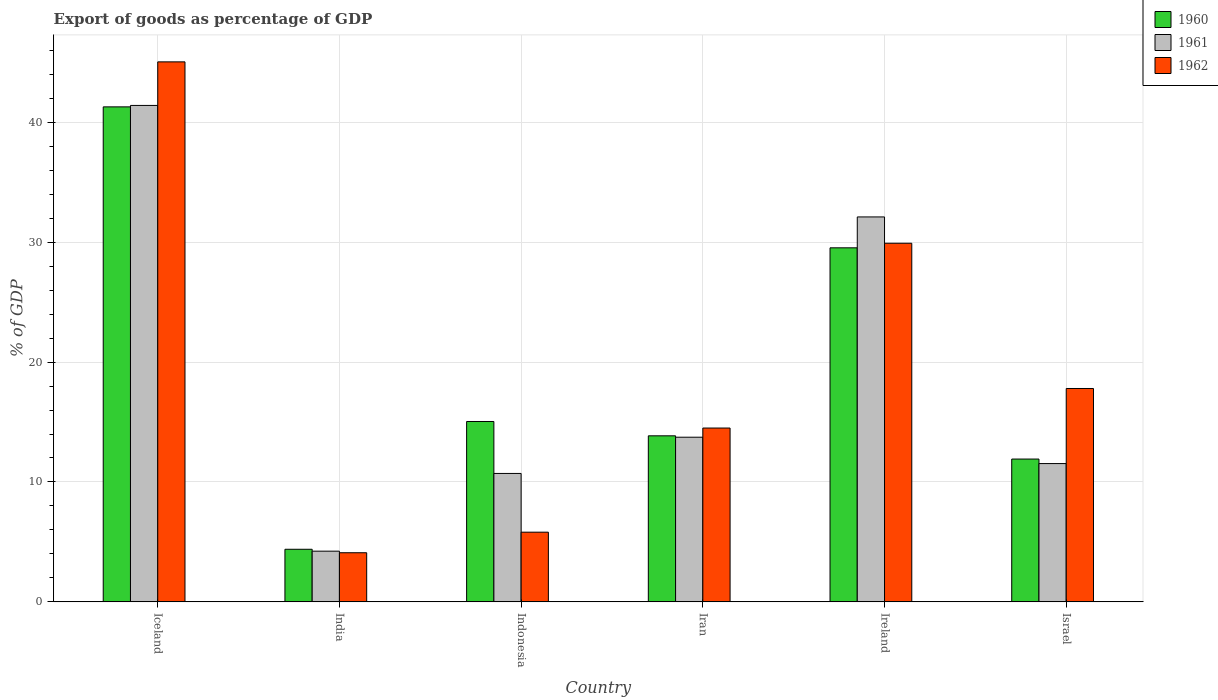How many groups of bars are there?
Make the answer very short. 6. Are the number of bars per tick equal to the number of legend labels?
Your response must be concise. Yes. How many bars are there on the 2nd tick from the left?
Your response must be concise. 3. How many bars are there on the 4th tick from the right?
Ensure brevity in your answer.  3. What is the label of the 4th group of bars from the left?
Provide a succinct answer. Iran. What is the export of goods as percentage of GDP in 1960 in Ireland?
Ensure brevity in your answer.  29.53. Across all countries, what is the maximum export of goods as percentage of GDP in 1960?
Keep it short and to the point. 41.28. Across all countries, what is the minimum export of goods as percentage of GDP in 1960?
Ensure brevity in your answer.  4.39. In which country was the export of goods as percentage of GDP in 1961 maximum?
Ensure brevity in your answer.  Iceland. What is the total export of goods as percentage of GDP in 1962 in the graph?
Keep it short and to the point. 117.15. What is the difference between the export of goods as percentage of GDP in 1960 in India and that in Indonesia?
Ensure brevity in your answer.  -10.66. What is the difference between the export of goods as percentage of GDP in 1960 in Iceland and the export of goods as percentage of GDP in 1962 in Iran?
Your answer should be compact. 26.79. What is the average export of goods as percentage of GDP in 1961 per country?
Your response must be concise. 18.95. What is the difference between the export of goods as percentage of GDP of/in 1961 and export of goods as percentage of GDP of/in 1962 in Iceland?
Give a very brief answer. -3.63. What is the ratio of the export of goods as percentage of GDP in 1960 in Indonesia to that in Israel?
Keep it short and to the point. 1.26. Is the export of goods as percentage of GDP in 1960 in Indonesia less than that in Ireland?
Make the answer very short. Yes. Is the difference between the export of goods as percentage of GDP in 1961 in Iceland and Iran greater than the difference between the export of goods as percentage of GDP in 1962 in Iceland and Iran?
Give a very brief answer. No. What is the difference between the highest and the second highest export of goods as percentage of GDP in 1960?
Give a very brief answer. 11.76. What is the difference between the highest and the lowest export of goods as percentage of GDP in 1961?
Your response must be concise. 37.17. How many bars are there?
Offer a very short reply. 18. Are all the bars in the graph horizontal?
Give a very brief answer. No. How many countries are there in the graph?
Your answer should be very brief. 6. What is the difference between two consecutive major ticks on the Y-axis?
Offer a terse response. 10. Are the values on the major ticks of Y-axis written in scientific E-notation?
Your answer should be compact. No. Does the graph contain any zero values?
Keep it short and to the point. No. What is the title of the graph?
Keep it short and to the point. Export of goods as percentage of GDP. What is the label or title of the X-axis?
Provide a short and direct response. Country. What is the label or title of the Y-axis?
Give a very brief answer. % of GDP. What is the % of GDP of 1960 in Iceland?
Provide a succinct answer. 41.28. What is the % of GDP in 1961 in Iceland?
Provide a short and direct response. 41.4. What is the % of GDP in 1962 in Iceland?
Your answer should be very brief. 45.03. What is the % of GDP of 1960 in India?
Provide a succinct answer. 4.39. What is the % of GDP in 1961 in India?
Provide a succinct answer. 4.23. What is the % of GDP of 1962 in India?
Make the answer very short. 4.1. What is the % of GDP in 1960 in Indonesia?
Provide a short and direct response. 15.04. What is the % of GDP of 1961 in Indonesia?
Provide a short and direct response. 10.71. What is the % of GDP in 1962 in Indonesia?
Your answer should be compact. 5.81. What is the % of GDP in 1960 in Iran?
Your answer should be compact. 13.85. What is the % of GDP of 1961 in Iran?
Ensure brevity in your answer.  13.73. What is the % of GDP in 1962 in Iran?
Offer a terse response. 14.5. What is the % of GDP in 1960 in Ireland?
Your answer should be compact. 29.53. What is the % of GDP in 1961 in Ireland?
Keep it short and to the point. 32.1. What is the % of GDP in 1962 in Ireland?
Offer a very short reply. 29.91. What is the % of GDP in 1960 in Israel?
Offer a very short reply. 11.91. What is the % of GDP in 1961 in Israel?
Give a very brief answer. 11.53. What is the % of GDP in 1962 in Israel?
Offer a terse response. 17.8. Across all countries, what is the maximum % of GDP of 1960?
Provide a succinct answer. 41.28. Across all countries, what is the maximum % of GDP of 1961?
Give a very brief answer. 41.4. Across all countries, what is the maximum % of GDP in 1962?
Give a very brief answer. 45.03. Across all countries, what is the minimum % of GDP in 1960?
Keep it short and to the point. 4.39. Across all countries, what is the minimum % of GDP of 1961?
Ensure brevity in your answer.  4.23. Across all countries, what is the minimum % of GDP in 1962?
Make the answer very short. 4.1. What is the total % of GDP in 1960 in the graph?
Provide a succinct answer. 116. What is the total % of GDP of 1961 in the graph?
Offer a very short reply. 113.71. What is the total % of GDP in 1962 in the graph?
Give a very brief answer. 117.15. What is the difference between the % of GDP of 1960 in Iceland and that in India?
Provide a short and direct response. 36.9. What is the difference between the % of GDP in 1961 in Iceland and that in India?
Give a very brief answer. 37.17. What is the difference between the % of GDP in 1962 in Iceland and that in India?
Your response must be concise. 40.94. What is the difference between the % of GDP in 1960 in Iceland and that in Indonesia?
Offer a very short reply. 26.24. What is the difference between the % of GDP in 1961 in Iceland and that in Indonesia?
Offer a very short reply. 30.69. What is the difference between the % of GDP of 1962 in Iceland and that in Indonesia?
Provide a succinct answer. 39.22. What is the difference between the % of GDP of 1960 in Iceland and that in Iran?
Keep it short and to the point. 27.43. What is the difference between the % of GDP in 1961 in Iceland and that in Iran?
Your answer should be very brief. 27.67. What is the difference between the % of GDP of 1962 in Iceland and that in Iran?
Your answer should be compact. 30.54. What is the difference between the % of GDP of 1960 in Iceland and that in Ireland?
Your answer should be very brief. 11.76. What is the difference between the % of GDP in 1961 in Iceland and that in Ireland?
Your response must be concise. 9.3. What is the difference between the % of GDP of 1962 in Iceland and that in Ireland?
Your answer should be very brief. 15.13. What is the difference between the % of GDP in 1960 in Iceland and that in Israel?
Provide a succinct answer. 29.37. What is the difference between the % of GDP in 1961 in Iceland and that in Israel?
Ensure brevity in your answer.  29.87. What is the difference between the % of GDP of 1962 in Iceland and that in Israel?
Provide a succinct answer. 27.24. What is the difference between the % of GDP in 1960 in India and that in Indonesia?
Give a very brief answer. -10.66. What is the difference between the % of GDP in 1961 in India and that in Indonesia?
Ensure brevity in your answer.  -6.48. What is the difference between the % of GDP in 1962 in India and that in Indonesia?
Your answer should be very brief. -1.72. What is the difference between the % of GDP of 1960 in India and that in Iran?
Your answer should be very brief. -9.46. What is the difference between the % of GDP of 1961 in India and that in Iran?
Offer a terse response. -9.5. What is the difference between the % of GDP of 1962 in India and that in Iran?
Offer a terse response. -10.4. What is the difference between the % of GDP in 1960 in India and that in Ireland?
Your response must be concise. -25.14. What is the difference between the % of GDP of 1961 in India and that in Ireland?
Ensure brevity in your answer.  -27.87. What is the difference between the % of GDP in 1962 in India and that in Ireland?
Keep it short and to the point. -25.81. What is the difference between the % of GDP of 1960 in India and that in Israel?
Provide a short and direct response. -7.52. What is the difference between the % of GDP of 1961 in India and that in Israel?
Make the answer very short. -7.3. What is the difference between the % of GDP of 1962 in India and that in Israel?
Make the answer very short. -13.7. What is the difference between the % of GDP of 1960 in Indonesia and that in Iran?
Provide a succinct answer. 1.19. What is the difference between the % of GDP of 1961 in Indonesia and that in Iran?
Make the answer very short. -3.02. What is the difference between the % of GDP in 1962 in Indonesia and that in Iran?
Your response must be concise. -8.68. What is the difference between the % of GDP of 1960 in Indonesia and that in Ireland?
Offer a terse response. -14.48. What is the difference between the % of GDP in 1961 in Indonesia and that in Ireland?
Your answer should be compact. -21.39. What is the difference between the % of GDP of 1962 in Indonesia and that in Ireland?
Offer a terse response. -24.1. What is the difference between the % of GDP of 1960 in Indonesia and that in Israel?
Make the answer very short. 3.13. What is the difference between the % of GDP of 1961 in Indonesia and that in Israel?
Give a very brief answer. -0.82. What is the difference between the % of GDP in 1962 in Indonesia and that in Israel?
Keep it short and to the point. -11.98. What is the difference between the % of GDP of 1960 in Iran and that in Ireland?
Provide a short and direct response. -15.68. What is the difference between the % of GDP in 1961 in Iran and that in Ireland?
Offer a terse response. -18.37. What is the difference between the % of GDP in 1962 in Iran and that in Ireland?
Give a very brief answer. -15.41. What is the difference between the % of GDP of 1960 in Iran and that in Israel?
Provide a short and direct response. 1.94. What is the difference between the % of GDP in 1961 in Iran and that in Israel?
Give a very brief answer. 2.2. What is the difference between the % of GDP of 1962 in Iran and that in Israel?
Keep it short and to the point. -3.3. What is the difference between the % of GDP of 1960 in Ireland and that in Israel?
Provide a short and direct response. 17.62. What is the difference between the % of GDP of 1961 in Ireland and that in Israel?
Your response must be concise. 20.57. What is the difference between the % of GDP of 1962 in Ireland and that in Israel?
Your answer should be very brief. 12.11. What is the difference between the % of GDP in 1960 in Iceland and the % of GDP in 1961 in India?
Your response must be concise. 37.05. What is the difference between the % of GDP of 1960 in Iceland and the % of GDP of 1962 in India?
Your answer should be very brief. 37.19. What is the difference between the % of GDP of 1961 in Iceland and the % of GDP of 1962 in India?
Provide a short and direct response. 37.3. What is the difference between the % of GDP in 1960 in Iceland and the % of GDP in 1961 in Indonesia?
Provide a succinct answer. 30.57. What is the difference between the % of GDP in 1960 in Iceland and the % of GDP in 1962 in Indonesia?
Provide a short and direct response. 35.47. What is the difference between the % of GDP in 1961 in Iceland and the % of GDP in 1962 in Indonesia?
Give a very brief answer. 35.59. What is the difference between the % of GDP of 1960 in Iceland and the % of GDP of 1961 in Iran?
Provide a succinct answer. 27.55. What is the difference between the % of GDP of 1960 in Iceland and the % of GDP of 1962 in Iran?
Your answer should be very brief. 26.79. What is the difference between the % of GDP of 1961 in Iceland and the % of GDP of 1962 in Iran?
Your answer should be very brief. 26.9. What is the difference between the % of GDP in 1960 in Iceland and the % of GDP in 1961 in Ireland?
Your response must be concise. 9.18. What is the difference between the % of GDP in 1960 in Iceland and the % of GDP in 1962 in Ireland?
Make the answer very short. 11.37. What is the difference between the % of GDP of 1961 in Iceland and the % of GDP of 1962 in Ireland?
Offer a very short reply. 11.49. What is the difference between the % of GDP of 1960 in Iceland and the % of GDP of 1961 in Israel?
Make the answer very short. 29.75. What is the difference between the % of GDP in 1960 in Iceland and the % of GDP in 1962 in Israel?
Your response must be concise. 23.49. What is the difference between the % of GDP of 1961 in Iceland and the % of GDP of 1962 in Israel?
Your answer should be very brief. 23.61. What is the difference between the % of GDP of 1960 in India and the % of GDP of 1961 in Indonesia?
Provide a succinct answer. -6.32. What is the difference between the % of GDP in 1960 in India and the % of GDP in 1962 in Indonesia?
Your response must be concise. -1.43. What is the difference between the % of GDP of 1961 in India and the % of GDP of 1962 in Indonesia?
Provide a succinct answer. -1.58. What is the difference between the % of GDP in 1960 in India and the % of GDP in 1961 in Iran?
Offer a terse response. -9.35. What is the difference between the % of GDP in 1960 in India and the % of GDP in 1962 in Iran?
Offer a very short reply. -10.11. What is the difference between the % of GDP of 1961 in India and the % of GDP of 1962 in Iran?
Ensure brevity in your answer.  -10.27. What is the difference between the % of GDP in 1960 in India and the % of GDP in 1961 in Ireland?
Keep it short and to the point. -27.72. What is the difference between the % of GDP in 1960 in India and the % of GDP in 1962 in Ireland?
Offer a terse response. -25.52. What is the difference between the % of GDP in 1961 in India and the % of GDP in 1962 in Ireland?
Ensure brevity in your answer.  -25.68. What is the difference between the % of GDP of 1960 in India and the % of GDP of 1961 in Israel?
Your answer should be very brief. -7.15. What is the difference between the % of GDP of 1960 in India and the % of GDP of 1962 in Israel?
Provide a succinct answer. -13.41. What is the difference between the % of GDP of 1961 in India and the % of GDP of 1962 in Israel?
Make the answer very short. -13.57. What is the difference between the % of GDP of 1960 in Indonesia and the % of GDP of 1961 in Iran?
Your answer should be compact. 1.31. What is the difference between the % of GDP in 1960 in Indonesia and the % of GDP in 1962 in Iran?
Give a very brief answer. 0.55. What is the difference between the % of GDP of 1961 in Indonesia and the % of GDP of 1962 in Iran?
Make the answer very short. -3.79. What is the difference between the % of GDP in 1960 in Indonesia and the % of GDP in 1961 in Ireland?
Make the answer very short. -17.06. What is the difference between the % of GDP in 1960 in Indonesia and the % of GDP in 1962 in Ireland?
Offer a very short reply. -14.86. What is the difference between the % of GDP of 1961 in Indonesia and the % of GDP of 1962 in Ireland?
Keep it short and to the point. -19.2. What is the difference between the % of GDP of 1960 in Indonesia and the % of GDP of 1961 in Israel?
Your answer should be very brief. 3.51. What is the difference between the % of GDP of 1960 in Indonesia and the % of GDP of 1962 in Israel?
Offer a very short reply. -2.75. What is the difference between the % of GDP of 1961 in Indonesia and the % of GDP of 1962 in Israel?
Ensure brevity in your answer.  -7.08. What is the difference between the % of GDP of 1960 in Iran and the % of GDP of 1961 in Ireland?
Your answer should be compact. -18.25. What is the difference between the % of GDP in 1960 in Iran and the % of GDP in 1962 in Ireland?
Give a very brief answer. -16.06. What is the difference between the % of GDP in 1961 in Iran and the % of GDP in 1962 in Ireland?
Offer a very short reply. -16.18. What is the difference between the % of GDP in 1960 in Iran and the % of GDP in 1961 in Israel?
Your answer should be compact. 2.31. What is the difference between the % of GDP in 1960 in Iran and the % of GDP in 1962 in Israel?
Provide a short and direct response. -3.95. What is the difference between the % of GDP of 1961 in Iran and the % of GDP of 1962 in Israel?
Make the answer very short. -4.06. What is the difference between the % of GDP of 1960 in Ireland and the % of GDP of 1961 in Israel?
Offer a very short reply. 17.99. What is the difference between the % of GDP in 1960 in Ireland and the % of GDP in 1962 in Israel?
Provide a succinct answer. 11.73. What is the difference between the % of GDP in 1961 in Ireland and the % of GDP in 1962 in Israel?
Make the answer very short. 14.31. What is the average % of GDP of 1960 per country?
Your answer should be compact. 19.33. What is the average % of GDP in 1961 per country?
Provide a succinct answer. 18.95. What is the average % of GDP of 1962 per country?
Make the answer very short. 19.52. What is the difference between the % of GDP in 1960 and % of GDP in 1961 in Iceland?
Provide a succinct answer. -0.12. What is the difference between the % of GDP in 1960 and % of GDP in 1962 in Iceland?
Provide a succinct answer. -3.75. What is the difference between the % of GDP in 1961 and % of GDP in 1962 in Iceland?
Your response must be concise. -3.63. What is the difference between the % of GDP in 1960 and % of GDP in 1961 in India?
Offer a terse response. 0.16. What is the difference between the % of GDP in 1960 and % of GDP in 1962 in India?
Make the answer very short. 0.29. What is the difference between the % of GDP in 1961 and % of GDP in 1962 in India?
Give a very brief answer. 0.13. What is the difference between the % of GDP of 1960 and % of GDP of 1961 in Indonesia?
Make the answer very short. 4.33. What is the difference between the % of GDP of 1960 and % of GDP of 1962 in Indonesia?
Ensure brevity in your answer.  9.23. What is the difference between the % of GDP of 1961 and % of GDP of 1962 in Indonesia?
Make the answer very short. 4.9. What is the difference between the % of GDP of 1960 and % of GDP of 1961 in Iran?
Give a very brief answer. 0.12. What is the difference between the % of GDP in 1960 and % of GDP in 1962 in Iran?
Your answer should be very brief. -0.65. What is the difference between the % of GDP in 1961 and % of GDP in 1962 in Iran?
Your response must be concise. -0.77. What is the difference between the % of GDP of 1960 and % of GDP of 1961 in Ireland?
Your response must be concise. -2.58. What is the difference between the % of GDP of 1960 and % of GDP of 1962 in Ireland?
Provide a short and direct response. -0.38. What is the difference between the % of GDP of 1961 and % of GDP of 1962 in Ireland?
Offer a terse response. 2.2. What is the difference between the % of GDP of 1960 and % of GDP of 1961 in Israel?
Keep it short and to the point. 0.38. What is the difference between the % of GDP of 1960 and % of GDP of 1962 in Israel?
Give a very brief answer. -5.88. What is the difference between the % of GDP in 1961 and % of GDP in 1962 in Israel?
Offer a terse response. -6.26. What is the ratio of the % of GDP in 1960 in Iceland to that in India?
Your answer should be compact. 9.41. What is the ratio of the % of GDP of 1961 in Iceland to that in India?
Ensure brevity in your answer.  9.79. What is the ratio of the % of GDP in 1962 in Iceland to that in India?
Offer a very short reply. 10.99. What is the ratio of the % of GDP of 1960 in Iceland to that in Indonesia?
Give a very brief answer. 2.74. What is the ratio of the % of GDP in 1961 in Iceland to that in Indonesia?
Your response must be concise. 3.87. What is the ratio of the % of GDP in 1962 in Iceland to that in Indonesia?
Offer a very short reply. 7.75. What is the ratio of the % of GDP in 1960 in Iceland to that in Iran?
Your response must be concise. 2.98. What is the ratio of the % of GDP in 1961 in Iceland to that in Iran?
Offer a very short reply. 3.01. What is the ratio of the % of GDP of 1962 in Iceland to that in Iran?
Your answer should be very brief. 3.11. What is the ratio of the % of GDP of 1960 in Iceland to that in Ireland?
Provide a short and direct response. 1.4. What is the ratio of the % of GDP in 1961 in Iceland to that in Ireland?
Give a very brief answer. 1.29. What is the ratio of the % of GDP of 1962 in Iceland to that in Ireland?
Provide a succinct answer. 1.51. What is the ratio of the % of GDP of 1960 in Iceland to that in Israel?
Provide a succinct answer. 3.47. What is the ratio of the % of GDP in 1961 in Iceland to that in Israel?
Offer a terse response. 3.59. What is the ratio of the % of GDP in 1962 in Iceland to that in Israel?
Ensure brevity in your answer.  2.53. What is the ratio of the % of GDP of 1960 in India to that in Indonesia?
Your answer should be very brief. 0.29. What is the ratio of the % of GDP of 1961 in India to that in Indonesia?
Make the answer very short. 0.39. What is the ratio of the % of GDP of 1962 in India to that in Indonesia?
Your answer should be compact. 0.7. What is the ratio of the % of GDP of 1960 in India to that in Iran?
Keep it short and to the point. 0.32. What is the ratio of the % of GDP of 1961 in India to that in Iran?
Give a very brief answer. 0.31. What is the ratio of the % of GDP in 1962 in India to that in Iran?
Keep it short and to the point. 0.28. What is the ratio of the % of GDP of 1960 in India to that in Ireland?
Keep it short and to the point. 0.15. What is the ratio of the % of GDP of 1961 in India to that in Ireland?
Your response must be concise. 0.13. What is the ratio of the % of GDP in 1962 in India to that in Ireland?
Offer a very short reply. 0.14. What is the ratio of the % of GDP of 1960 in India to that in Israel?
Ensure brevity in your answer.  0.37. What is the ratio of the % of GDP in 1961 in India to that in Israel?
Your answer should be very brief. 0.37. What is the ratio of the % of GDP in 1962 in India to that in Israel?
Offer a very short reply. 0.23. What is the ratio of the % of GDP in 1960 in Indonesia to that in Iran?
Your answer should be compact. 1.09. What is the ratio of the % of GDP of 1961 in Indonesia to that in Iran?
Keep it short and to the point. 0.78. What is the ratio of the % of GDP of 1962 in Indonesia to that in Iran?
Keep it short and to the point. 0.4. What is the ratio of the % of GDP of 1960 in Indonesia to that in Ireland?
Provide a short and direct response. 0.51. What is the ratio of the % of GDP of 1961 in Indonesia to that in Ireland?
Your answer should be compact. 0.33. What is the ratio of the % of GDP of 1962 in Indonesia to that in Ireland?
Your answer should be very brief. 0.19. What is the ratio of the % of GDP of 1960 in Indonesia to that in Israel?
Provide a succinct answer. 1.26. What is the ratio of the % of GDP of 1961 in Indonesia to that in Israel?
Keep it short and to the point. 0.93. What is the ratio of the % of GDP in 1962 in Indonesia to that in Israel?
Ensure brevity in your answer.  0.33. What is the ratio of the % of GDP in 1960 in Iran to that in Ireland?
Provide a succinct answer. 0.47. What is the ratio of the % of GDP in 1961 in Iran to that in Ireland?
Your response must be concise. 0.43. What is the ratio of the % of GDP in 1962 in Iran to that in Ireland?
Your answer should be compact. 0.48. What is the ratio of the % of GDP of 1960 in Iran to that in Israel?
Offer a very short reply. 1.16. What is the ratio of the % of GDP in 1961 in Iran to that in Israel?
Your answer should be compact. 1.19. What is the ratio of the % of GDP in 1962 in Iran to that in Israel?
Provide a succinct answer. 0.81. What is the ratio of the % of GDP in 1960 in Ireland to that in Israel?
Your answer should be very brief. 2.48. What is the ratio of the % of GDP of 1961 in Ireland to that in Israel?
Your response must be concise. 2.78. What is the ratio of the % of GDP in 1962 in Ireland to that in Israel?
Your answer should be compact. 1.68. What is the difference between the highest and the second highest % of GDP in 1960?
Provide a succinct answer. 11.76. What is the difference between the highest and the second highest % of GDP of 1961?
Your answer should be compact. 9.3. What is the difference between the highest and the second highest % of GDP in 1962?
Offer a terse response. 15.13. What is the difference between the highest and the lowest % of GDP in 1960?
Offer a very short reply. 36.9. What is the difference between the highest and the lowest % of GDP in 1961?
Offer a very short reply. 37.17. What is the difference between the highest and the lowest % of GDP of 1962?
Provide a succinct answer. 40.94. 